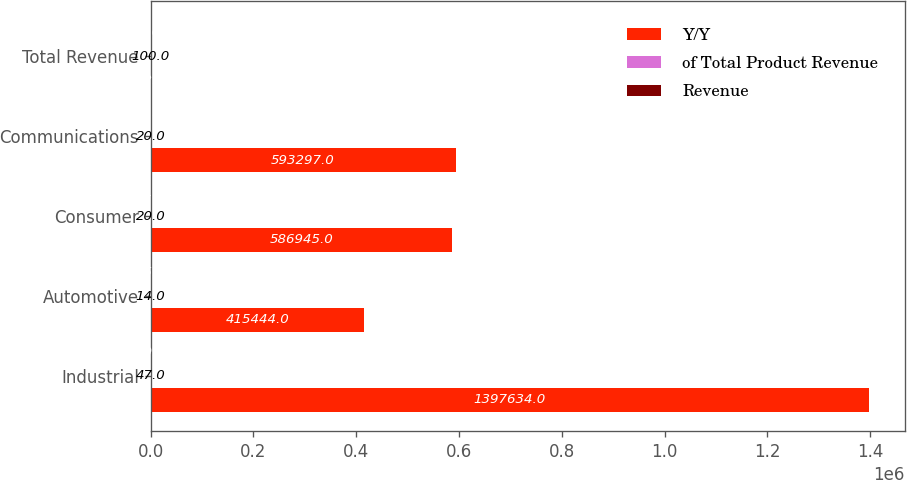Convert chart to OTSL. <chart><loc_0><loc_0><loc_500><loc_500><stacked_bar_chart><ecel><fcel>Industrial<fcel>Automotive<fcel>Consumer<fcel>Communications<fcel>Total Revenue<nl><fcel>Y/Y<fcel>1.39763e+06<fcel>415444<fcel>586945<fcel>593297<fcel>22.5<nl><fcel>of Total Product Revenue<fcel>47<fcel>14<fcel>20<fcel>20<fcel>100<nl><fcel>Revenue<fcel>10<fcel>25<fcel>6<fcel>11<fcel>8<nl></chart> 